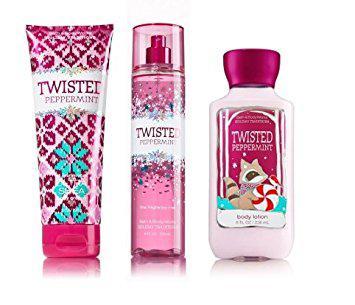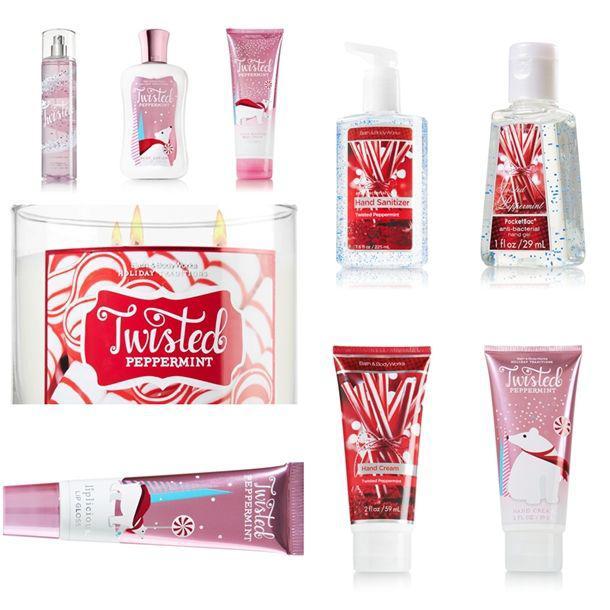The first image is the image on the left, the second image is the image on the right. For the images shown, is this caption "An image with no more than four items includes exactly one product that stands on its cap." true? Answer yes or no. Yes. The first image is the image on the left, the second image is the image on the right. Considering the images on both sides, is "One of the images shows four or more products." valid? Answer yes or no. Yes. 